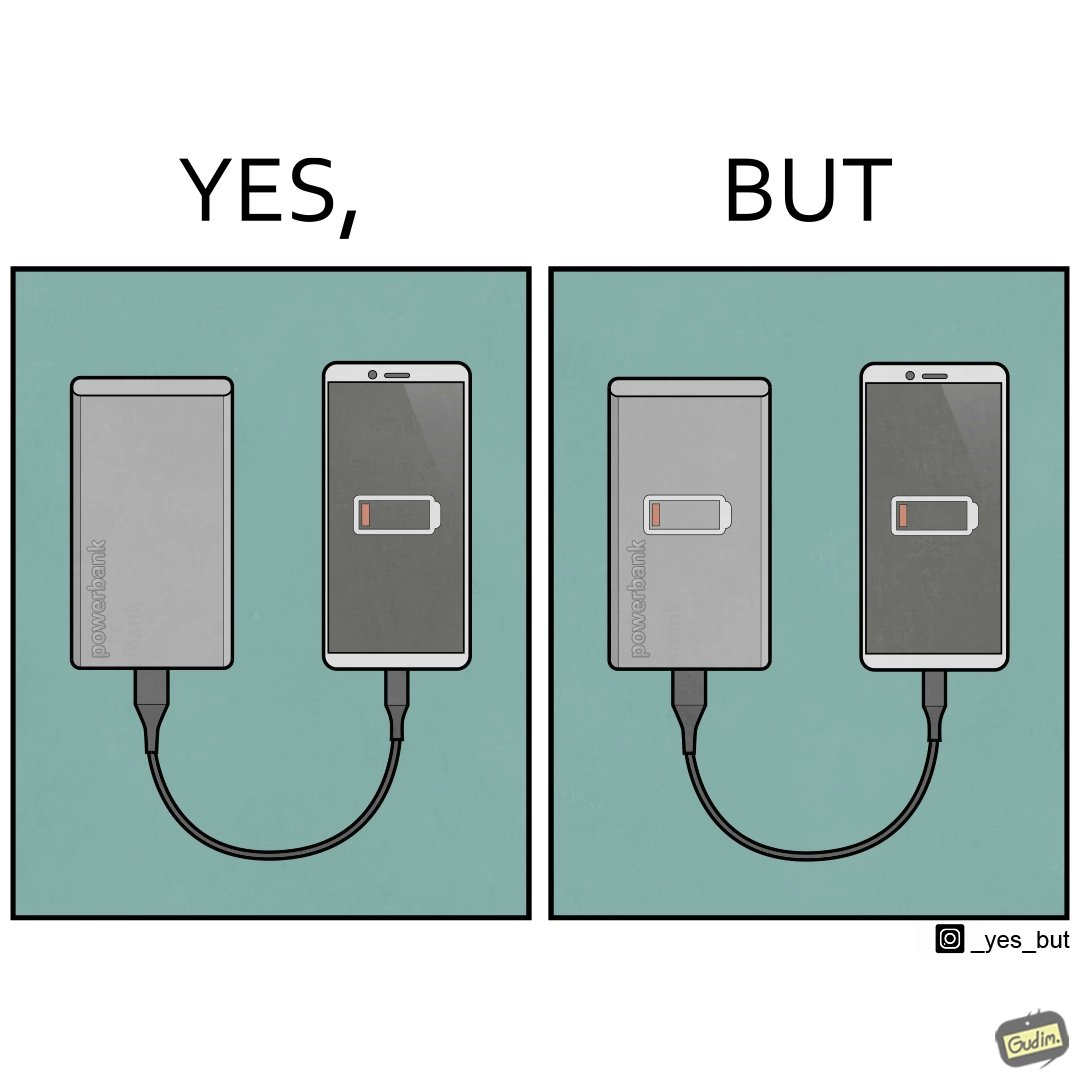What makes this image funny or satirical? This image is funny because its an assumed expectation that  the dead phone will be rescued by the power bank, but here the power bank is also dead and of no use. 